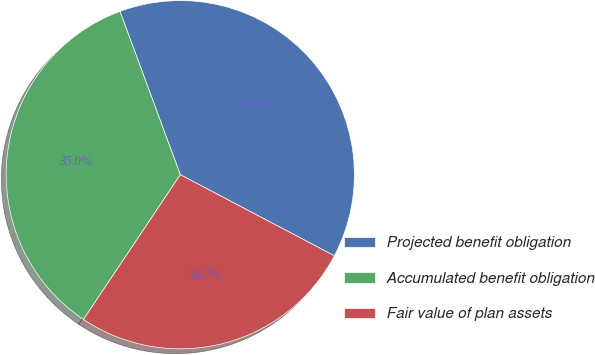Convert chart. <chart><loc_0><loc_0><loc_500><loc_500><pie_chart><fcel>Projected benefit obligation<fcel>Accumulated benefit obligation<fcel>Fair value of plan assets<nl><fcel>38.34%<fcel>34.99%<fcel>26.67%<nl></chart> 